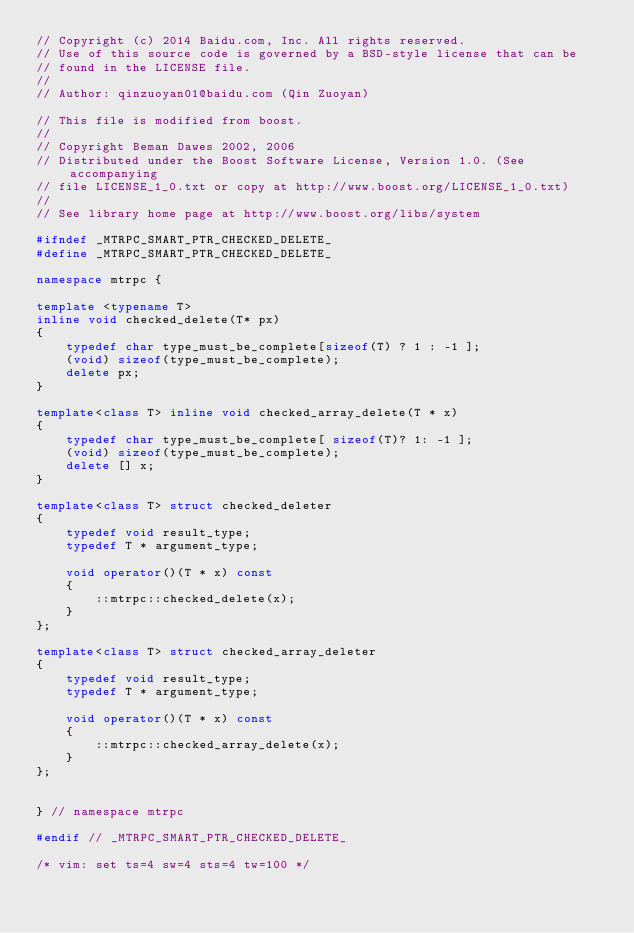<code> <loc_0><loc_0><loc_500><loc_500><_C++_>// Copyright (c) 2014 Baidu.com, Inc. All rights reserved.
// Use of this source code is governed by a BSD-style license that can be
// found in the LICENSE file.
//
// Author: qinzuoyan01@baidu.com (Qin Zuoyan)

// This file is modified from boost.
//
// Copyright Beman Dawes 2002, 2006
// Distributed under the Boost Software License, Version 1.0. (See accompanying
// file LICENSE_1_0.txt or copy at http://www.boost.org/LICENSE_1_0.txt)
//
// See library home page at http://www.boost.org/libs/system

#ifndef _MTRPC_SMART_PTR_CHECKED_DELETE_
#define _MTRPC_SMART_PTR_CHECKED_DELETE_

namespace mtrpc {

template <typename T>
inline void checked_delete(T* px)
{
    typedef char type_must_be_complete[sizeof(T) ? 1 : -1 ];
    (void) sizeof(type_must_be_complete);
    delete px;
}

template<class T> inline void checked_array_delete(T * x)
{
    typedef char type_must_be_complete[ sizeof(T)? 1: -1 ];
    (void) sizeof(type_must_be_complete);
    delete [] x;
}

template<class T> struct checked_deleter
{
    typedef void result_type;
    typedef T * argument_type;

    void operator()(T * x) const
    {
        ::mtrpc::checked_delete(x);
    }
};

template<class T> struct checked_array_deleter
{
    typedef void result_type;
    typedef T * argument_type;

    void operator()(T * x) const
    {
        ::mtrpc::checked_array_delete(x);
    }
};


} // namespace mtrpc

#endif // _MTRPC_SMART_PTR_CHECKED_DELETE_

/* vim: set ts=4 sw=4 sts=4 tw=100 */
</code> 